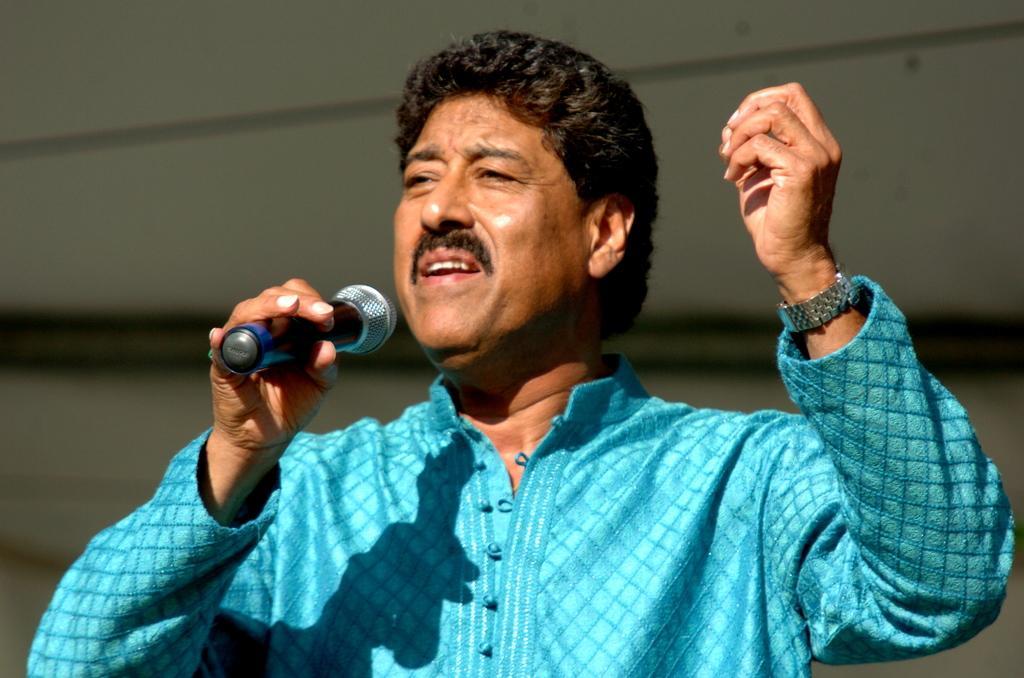Could you give a brief overview of what you see in this image? This is the man standing and singing a song. He wore blue color kurta ,wrist watch,and he is holding a mike. 